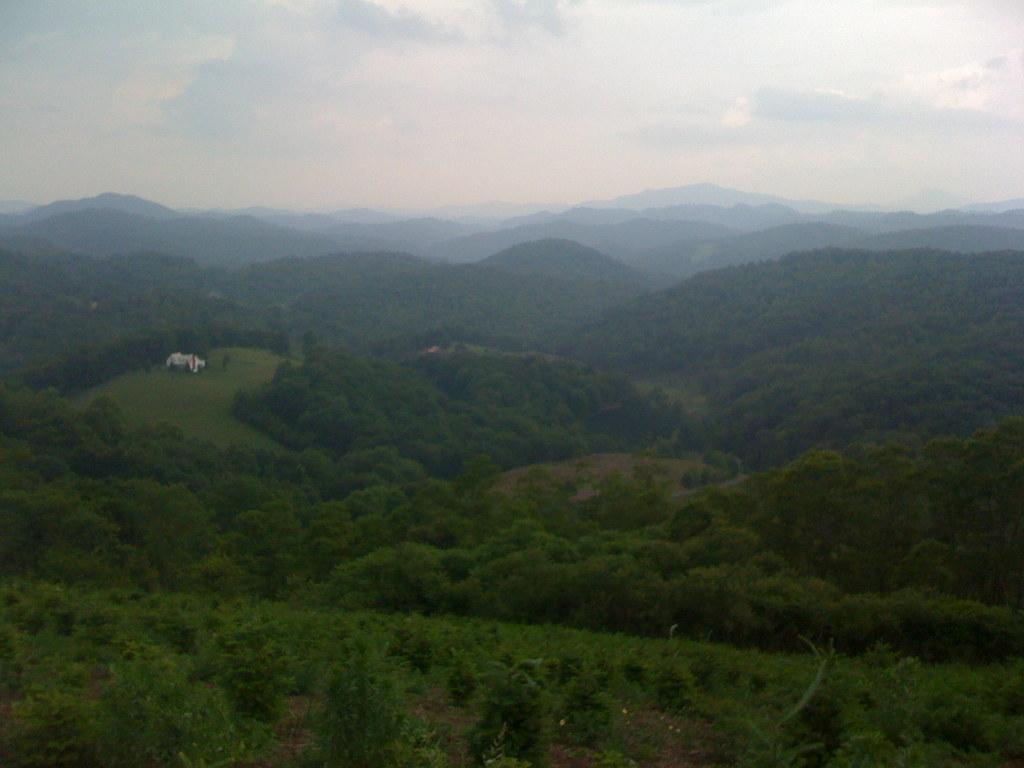In one or two sentences, can you explain what this image depicts? In this image I see the mountains and number of trees and I see the sky in the background. 